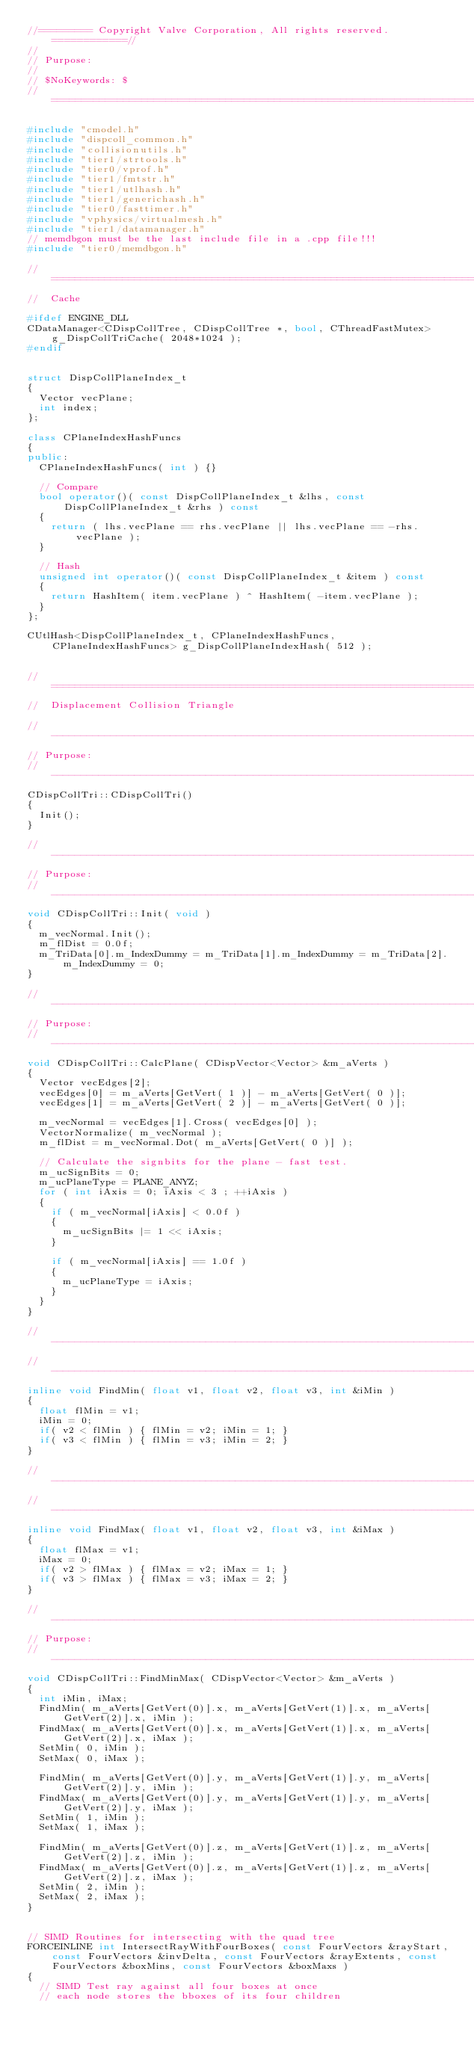<code> <loc_0><loc_0><loc_500><loc_500><_C++_>//========= Copyright Valve Corporation, All rights reserved. ============//
//
// Purpose: 
//
// $NoKeywords: $
//=============================================================================//

#include "cmodel.h"
#include "dispcoll_common.h"
#include "collisionutils.h"
#include "tier1/strtools.h"
#include "tier0/vprof.h"
#include "tier1/fmtstr.h"
#include "tier1/utlhash.h"
#include "tier1/generichash.h"
#include "tier0/fasttimer.h"
#include "vphysics/virtualmesh.h"
#include "tier1/datamanager.h"
// memdbgon must be the last include file in a .cpp file!!!
#include "tier0/memdbgon.h"

//=============================================================================
//	Cache

#ifdef ENGINE_DLL
CDataManager<CDispCollTree, CDispCollTree *, bool, CThreadFastMutex> g_DispCollTriCache( 2048*1024 );
#endif


struct DispCollPlaneIndex_t
{
	Vector vecPlane;
	int index;
};

class CPlaneIndexHashFuncs
{
public:
	CPlaneIndexHashFuncs( int ) {}

	// Compare
	bool operator()( const DispCollPlaneIndex_t &lhs, const DispCollPlaneIndex_t &rhs ) const
	{
		return ( lhs.vecPlane == rhs.vecPlane || lhs.vecPlane == -rhs.vecPlane );
	}

	// Hash
	unsigned int operator()( const DispCollPlaneIndex_t &item ) const
	{
		return HashItem( item.vecPlane ) ^ HashItem( -item.vecPlane );
	}
};

CUtlHash<DispCollPlaneIndex_t, CPlaneIndexHashFuncs, CPlaneIndexHashFuncs> g_DispCollPlaneIndexHash( 512 );


//=============================================================================
//	Displacement Collision Triangle

//-----------------------------------------------------------------------------
// Purpose:
//-----------------------------------------------------------------------------
CDispCollTri::CDispCollTri()
{
	Init();
}

//-----------------------------------------------------------------------------
// Purpose:
//-----------------------------------------------------------------------------
void CDispCollTri::Init( void )
{
	m_vecNormal.Init();
	m_flDist = 0.0f;
	m_TriData[0].m_IndexDummy = m_TriData[1].m_IndexDummy = m_TriData[2].m_IndexDummy = 0;
}

//-----------------------------------------------------------------------------
// Purpose:
//-----------------------------------------------------------------------------
void CDispCollTri::CalcPlane( CDispVector<Vector> &m_aVerts )
{
	Vector vecEdges[2];
	vecEdges[0] = m_aVerts[GetVert( 1 )] - m_aVerts[GetVert( 0 )];
	vecEdges[1] = m_aVerts[GetVert( 2 )] - m_aVerts[GetVert( 0 )];
	
	m_vecNormal = vecEdges[1].Cross( vecEdges[0] );
	VectorNormalize( m_vecNormal );
	m_flDist = m_vecNormal.Dot( m_aVerts[GetVert( 0 )] );

	// Calculate the signbits for the plane - fast test.
	m_ucSignBits = 0;
	m_ucPlaneType = PLANE_ANYZ;
	for ( int iAxis = 0; iAxis < 3 ; ++iAxis )
	{
		if ( m_vecNormal[iAxis] < 0.0f )
		{
			m_ucSignBits |= 1 << iAxis;
		}

		if ( m_vecNormal[iAxis] == 1.0f )
		{
			m_ucPlaneType = iAxis;
		}
	}
}

//-----------------------------------------------------------------------------
//-----------------------------------------------------------------------------
inline void FindMin( float v1, float v2, float v3, int &iMin )
{
	float flMin = v1; 
	iMin = 0;
	if( v2 < flMin ) { flMin = v2; iMin = 1; }
	if( v3 < flMin ) { flMin = v3; iMin = 2; }
}

//-----------------------------------------------------------------------------
//-----------------------------------------------------------------------------
inline void FindMax( float v1, float v2, float v3, int &iMax )
{
	float flMax = v1;
	iMax = 0;
	if( v2 > flMax ) { flMax = v2; iMax = 1; }
	if( v3 > flMax ) { flMax = v3; iMax = 2; }
}

//-----------------------------------------------------------------------------
// Purpose:
//-----------------------------------------------------------------------------
void CDispCollTri::FindMinMax( CDispVector<Vector> &m_aVerts )
{
	int iMin, iMax;
	FindMin( m_aVerts[GetVert(0)].x, m_aVerts[GetVert(1)].x, m_aVerts[GetVert(2)].x, iMin );
	FindMax( m_aVerts[GetVert(0)].x, m_aVerts[GetVert(1)].x, m_aVerts[GetVert(2)].x, iMax );
	SetMin( 0, iMin );
	SetMax( 0, iMax );

	FindMin( m_aVerts[GetVert(0)].y, m_aVerts[GetVert(1)].y, m_aVerts[GetVert(2)].y, iMin );
	FindMax( m_aVerts[GetVert(0)].y, m_aVerts[GetVert(1)].y, m_aVerts[GetVert(2)].y, iMax );
	SetMin( 1, iMin );
	SetMax( 1, iMax );

	FindMin( m_aVerts[GetVert(0)].z, m_aVerts[GetVert(1)].z, m_aVerts[GetVert(2)].z, iMin );
	FindMax( m_aVerts[GetVert(0)].z, m_aVerts[GetVert(1)].z, m_aVerts[GetVert(2)].z, iMax );
	SetMin( 2, iMin );
	SetMax( 2, iMax );
}


// SIMD Routines for intersecting with the quad tree
FORCEINLINE int IntersectRayWithFourBoxes( const FourVectors &rayStart, const FourVectors &invDelta, const FourVectors &rayExtents, const FourVectors &boxMins, const FourVectors &boxMaxs )
{
	// SIMD Test ray against all four boxes at once
	// each node stores the bboxes of its four children</code> 